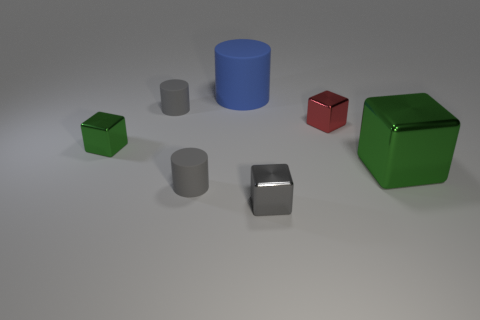There is a small matte cylinder that is behind the small shiny cube that is left of the large blue cylinder; how many large blue cylinders are behind it?
Your response must be concise. 1. What shape is the red thing?
Provide a short and direct response. Cube. What number of other things are the same material as the blue object?
Ensure brevity in your answer.  2. Do the gray metal thing and the red shiny object have the same size?
Your answer should be compact. Yes. What shape is the large object to the left of the tiny gray shiny cube?
Provide a succinct answer. Cylinder. What is the color of the rubber cylinder in front of the small matte object that is behind the red block?
Ensure brevity in your answer.  Gray. There is a green object that is right of the big rubber object; is it the same shape as the tiny gray metal thing in front of the red metallic cube?
Make the answer very short. Yes. What is the shape of the green metallic object that is the same size as the red metallic cube?
Your answer should be very brief. Cube. There is a large thing that is made of the same material as the gray block; what is its color?
Your response must be concise. Green. Does the small green metal object have the same shape as the small shiny thing on the right side of the tiny gray block?
Ensure brevity in your answer.  Yes. 